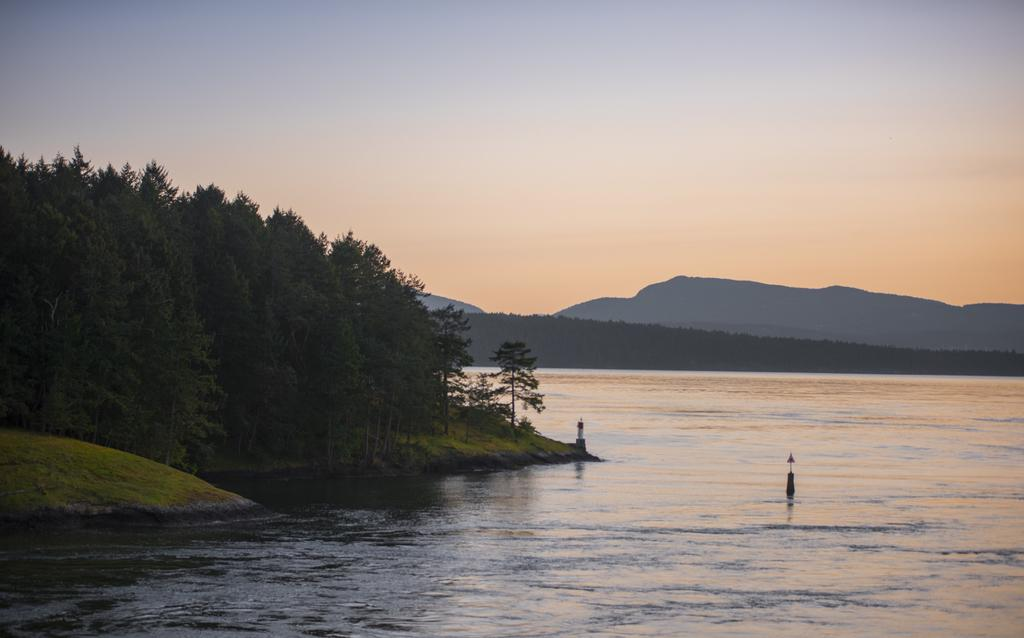What is present in the image that is not solid? There is water visible in the image. What type of vegetation can be seen on the left side of the image? There are trees on the left side of the image. What geographical features are visible in the background of the image? There are hills in the background of the image. What is visible in the sky in the image? The sky is visible in the background of the image. What type of fruit is the queen holding in the image? There is no queen or fruit present in the image. How does the image make you feel when you look at it? The image itself does not have emotions, but it may evoke feelings in the viewer. However, this question cannot be answered definitively based on the provided facts. 